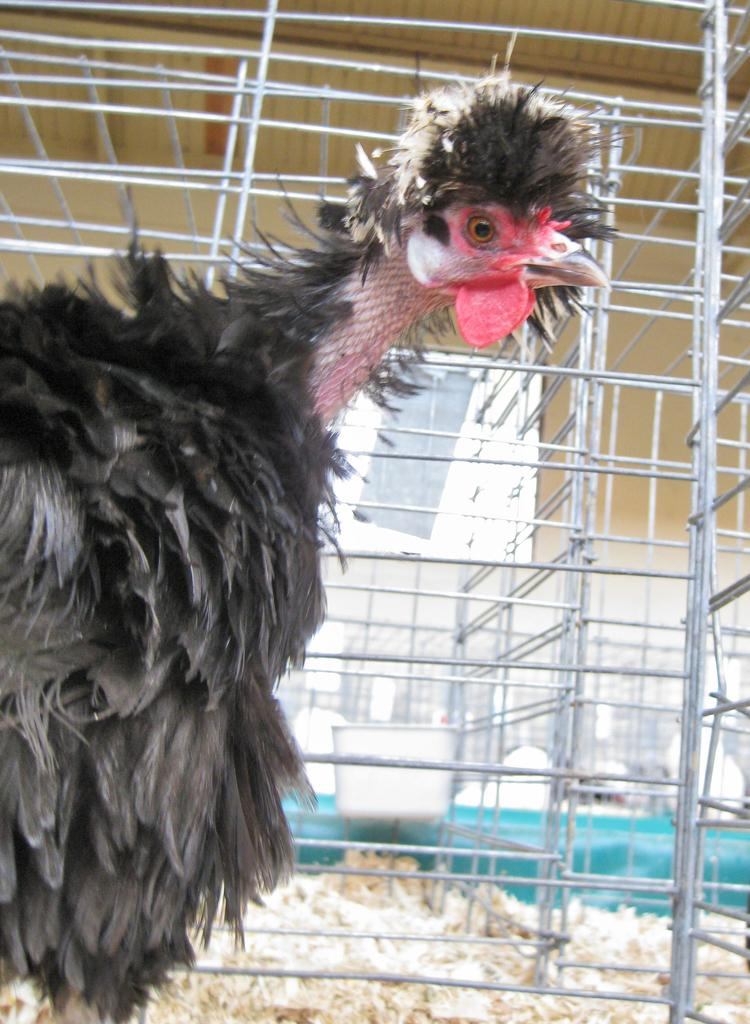What is the main subject in the foreground of the image? There is a bird in the foreground of the image. What type of objects can be seen in the background of the image? Metal rods are visible in the background of the image. Can you describe any other elements in the background of the image? There are other unspecified items in the background of the image. What type of advertisement can be seen on the bird's wings in the image? There is no advertisement visible on the bird's wings in the image. What type of waves can be seen crashing on the shore in the image? There is no shore or waves present in the image; it features a bird and metal rods in the background. 